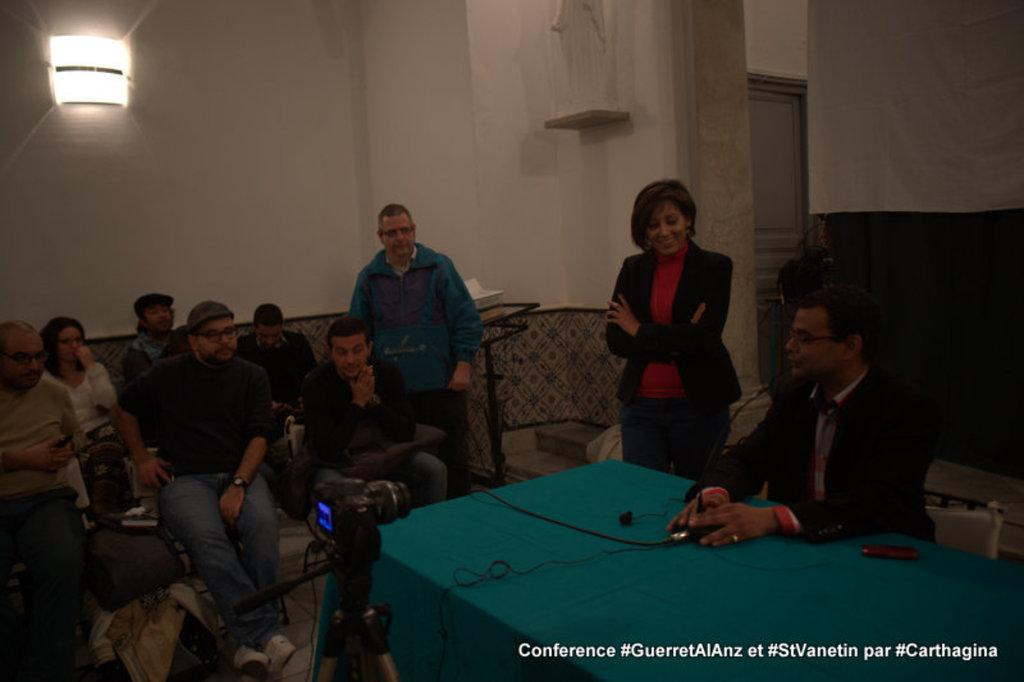How many people are in the image? There is a group of people in the image. What are the people in the image doing? Some people are sitting, while others are standing. What is in front of one person? There is a table in front of one person. What can be seen in the background of the image? There is a light and a wall in the background of the image. What type of silk is draped over the actor in the image? There is no actor or silk present in the image. How many ears of corn are visible on the table in the image? There is no corn present in the image; only a table is visible in front of one person. 